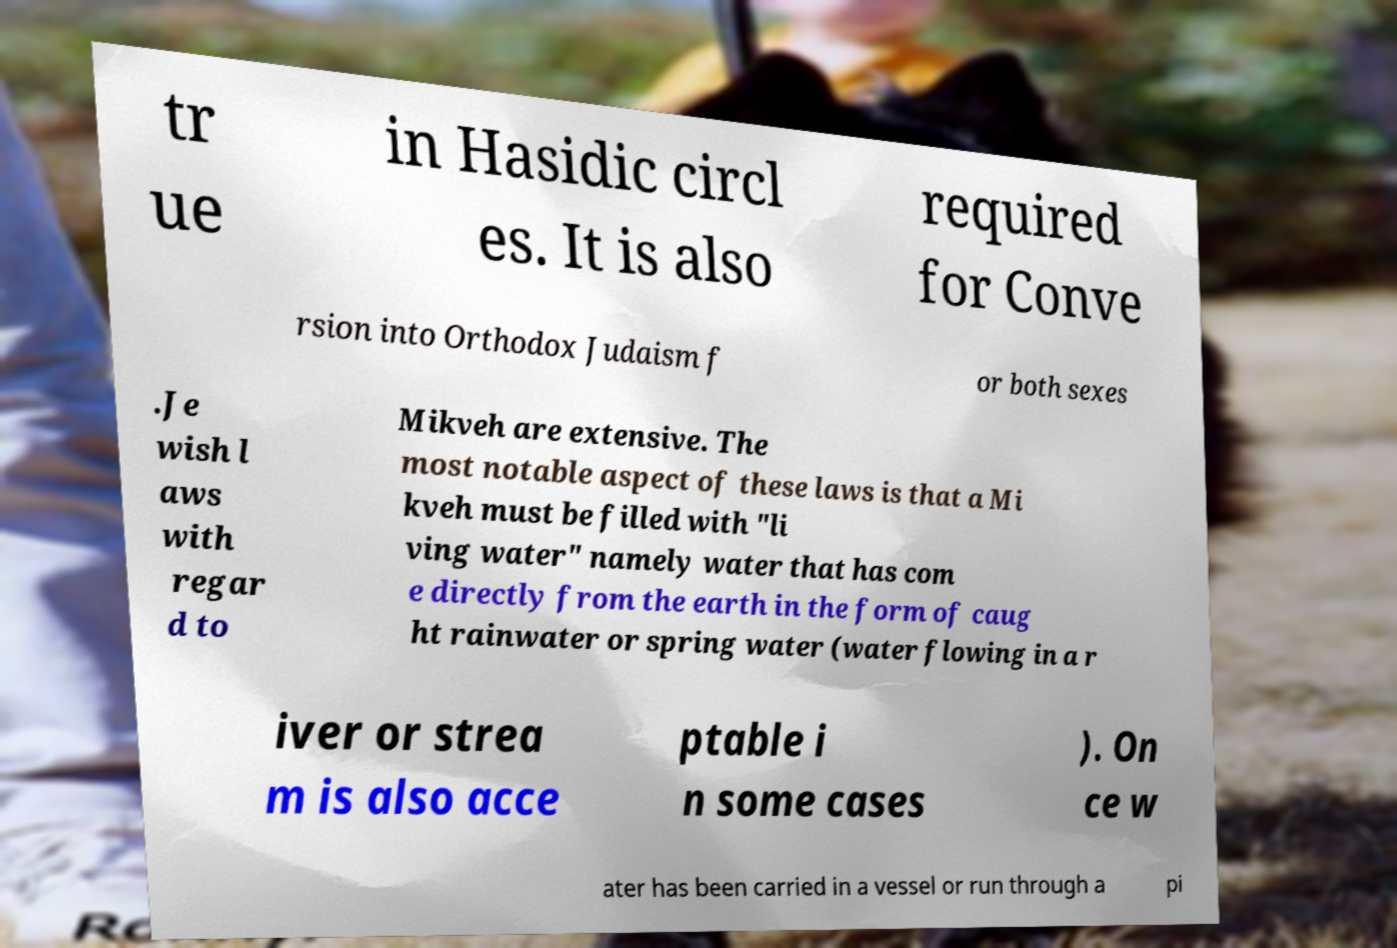There's text embedded in this image that I need extracted. Can you transcribe it verbatim? tr ue in Hasidic circl es. It is also required for Conve rsion into Orthodox Judaism f or both sexes .Je wish l aws with regar d to Mikveh are extensive. The most notable aspect of these laws is that a Mi kveh must be filled with "li ving water" namely water that has com e directly from the earth in the form of caug ht rainwater or spring water (water flowing in a r iver or strea m is also acce ptable i n some cases ). On ce w ater has been carried in a vessel or run through a pi 